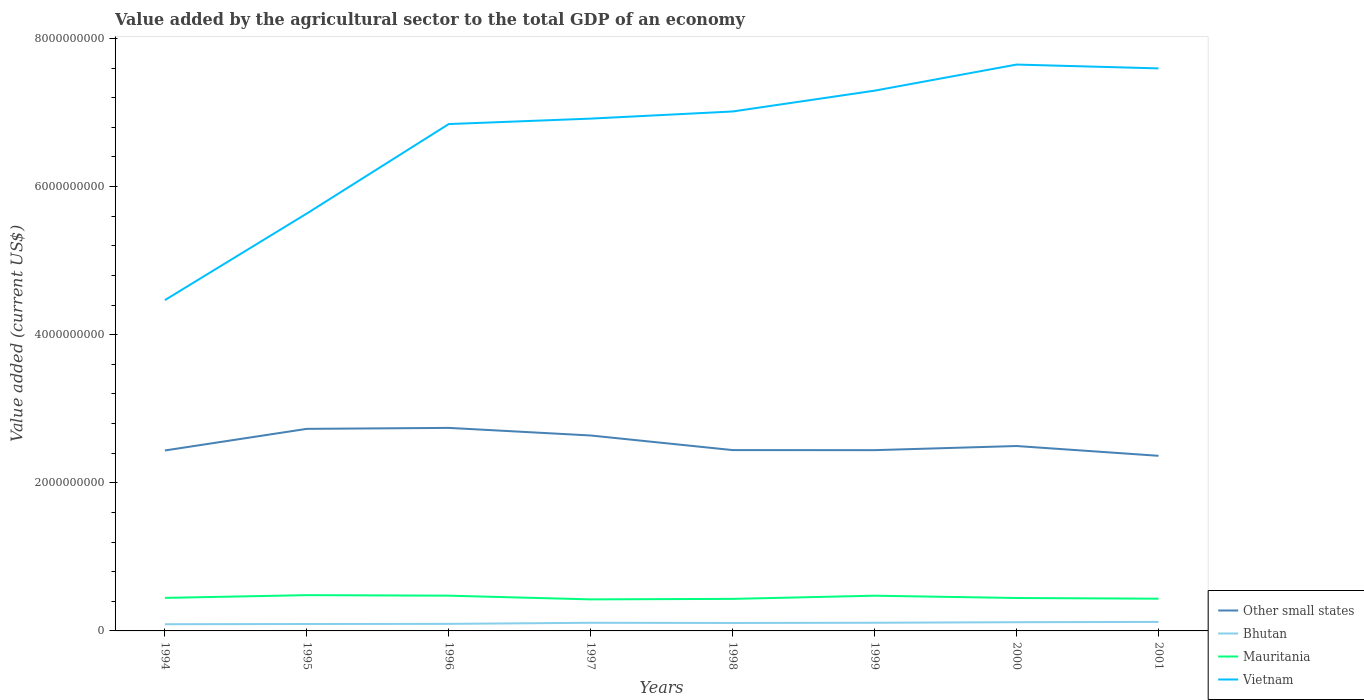How many different coloured lines are there?
Your answer should be very brief. 4. Across all years, what is the maximum value added by the agricultural sector to the total GDP in Mauritania?
Give a very brief answer. 4.26e+08. What is the total value added by the agricultural sector to the total GDP in Bhutan in the graph?
Your answer should be compact. -2.42e+07. What is the difference between the highest and the second highest value added by the agricultural sector to the total GDP in Other small states?
Offer a terse response. 3.77e+08. Are the values on the major ticks of Y-axis written in scientific E-notation?
Offer a terse response. No. What is the title of the graph?
Provide a short and direct response. Value added by the agricultural sector to the total GDP of an economy. Does "Monaco" appear as one of the legend labels in the graph?
Provide a succinct answer. No. What is the label or title of the Y-axis?
Your answer should be very brief. Value added (current US$). What is the Value added (current US$) of Other small states in 1994?
Provide a succinct answer. 2.44e+09. What is the Value added (current US$) in Bhutan in 1994?
Ensure brevity in your answer.  9.05e+07. What is the Value added (current US$) in Mauritania in 1994?
Make the answer very short. 4.46e+08. What is the Value added (current US$) of Vietnam in 1994?
Your answer should be compact. 4.47e+09. What is the Value added (current US$) in Other small states in 1995?
Offer a terse response. 2.73e+09. What is the Value added (current US$) of Bhutan in 1995?
Your answer should be compact. 9.35e+07. What is the Value added (current US$) in Mauritania in 1995?
Your answer should be compact. 4.83e+08. What is the Value added (current US$) of Vietnam in 1995?
Provide a short and direct response. 5.64e+09. What is the Value added (current US$) in Other small states in 1996?
Provide a short and direct response. 2.74e+09. What is the Value added (current US$) in Bhutan in 1996?
Provide a succinct answer. 9.55e+07. What is the Value added (current US$) in Mauritania in 1996?
Your response must be concise. 4.76e+08. What is the Value added (current US$) of Vietnam in 1996?
Your answer should be very brief. 6.84e+09. What is the Value added (current US$) of Other small states in 1997?
Make the answer very short. 2.64e+09. What is the Value added (current US$) in Bhutan in 1997?
Provide a short and direct response. 1.10e+08. What is the Value added (current US$) in Mauritania in 1997?
Your answer should be compact. 4.26e+08. What is the Value added (current US$) in Vietnam in 1997?
Your response must be concise. 6.92e+09. What is the Value added (current US$) of Other small states in 1998?
Keep it short and to the point. 2.44e+09. What is the Value added (current US$) of Bhutan in 1998?
Make the answer very short. 1.07e+08. What is the Value added (current US$) of Mauritania in 1998?
Your response must be concise. 4.33e+08. What is the Value added (current US$) of Vietnam in 1998?
Your answer should be compact. 7.01e+09. What is the Value added (current US$) of Other small states in 1999?
Keep it short and to the point. 2.44e+09. What is the Value added (current US$) of Bhutan in 1999?
Provide a succinct answer. 1.10e+08. What is the Value added (current US$) in Mauritania in 1999?
Make the answer very short. 4.76e+08. What is the Value added (current US$) of Vietnam in 1999?
Your response must be concise. 7.30e+09. What is the Value added (current US$) in Other small states in 2000?
Make the answer very short. 2.50e+09. What is the Value added (current US$) in Bhutan in 2000?
Offer a terse response. 1.18e+08. What is the Value added (current US$) in Mauritania in 2000?
Keep it short and to the point. 4.45e+08. What is the Value added (current US$) of Vietnam in 2000?
Keep it short and to the point. 7.65e+09. What is the Value added (current US$) of Other small states in 2001?
Provide a short and direct response. 2.36e+09. What is the Value added (current US$) of Bhutan in 2001?
Offer a very short reply. 1.22e+08. What is the Value added (current US$) in Mauritania in 2001?
Provide a succinct answer. 4.35e+08. What is the Value added (current US$) in Vietnam in 2001?
Offer a terse response. 7.60e+09. Across all years, what is the maximum Value added (current US$) in Other small states?
Your answer should be compact. 2.74e+09. Across all years, what is the maximum Value added (current US$) in Bhutan?
Offer a terse response. 1.22e+08. Across all years, what is the maximum Value added (current US$) in Mauritania?
Your response must be concise. 4.83e+08. Across all years, what is the maximum Value added (current US$) of Vietnam?
Your answer should be compact. 7.65e+09. Across all years, what is the minimum Value added (current US$) in Other small states?
Make the answer very short. 2.36e+09. Across all years, what is the minimum Value added (current US$) of Bhutan?
Your answer should be compact. 9.05e+07. Across all years, what is the minimum Value added (current US$) of Mauritania?
Provide a succinct answer. 4.26e+08. Across all years, what is the minimum Value added (current US$) of Vietnam?
Offer a very short reply. 4.47e+09. What is the total Value added (current US$) in Other small states in the graph?
Provide a succinct answer. 2.03e+1. What is the total Value added (current US$) in Bhutan in the graph?
Provide a succinct answer. 8.47e+08. What is the total Value added (current US$) in Mauritania in the graph?
Keep it short and to the point. 3.62e+09. What is the total Value added (current US$) of Vietnam in the graph?
Offer a very short reply. 5.34e+1. What is the difference between the Value added (current US$) of Other small states in 1994 and that in 1995?
Offer a very short reply. -2.92e+08. What is the difference between the Value added (current US$) in Bhutan in 1994 and that in 1995?
Your answer should be compact. -2.95e+06. What is the difference between the Value added (current US$) of Mauritania in 1994 and that in 1995?
Ensure brevity in your answer.  -3.70e+07. What is the difference between the Value added (current US$) in Vietnam in 1994 and that in 1995?
Your response must be concise. -1.17e+09. What is the difference between the Value added (current US$) in Other small states in 1994 and that in 1996?
Make the answer very short. -3.05e+08. What is the difference between the Value added (current US$) of Bhutan in 1994 and that in 1996?
Your answer should be very brief. -4.93e+06. What is the difference between the Value added (current US$) in Mauritania in 1994 and that in 1996?
Keep it short and to the point. -3.00e+07. What is the difference between the Value added (current US$) of Vietnam in 1994 and that in 1996?
Make the answer very short. -2.38e+09. What is the difference between the Value added (current US$) in Other small states in 1994 and that in 1997?
Ensure brevity in your answer.  -2.02e+08. What is the difference between the Value added (current US$) of Bhutan in 1994 and that in 1997?
Ensure brevity in your answer.  -1.93e+07. What is the difference between the Value added (current US$) in Mauritania in 1994 and that in 1997?
Give a very brief answer. 2.00e+07. What is the difference between the Value added (current US$) of Vietnam in 1994 and that in 1997?
Make the answer very short. -2.45e+09. What is the difference between the Value added (current US$) of Other small states in 1994 and that in 1998?
Your answer should be compact. -5.21e+06. What is the difference between the Value added (current US$) in Bhutan in 1994 and that in 1998?
Ensure brevity in your answer.  -1.69e+07. What is the difference between the Value added (current US$) of Mauritania in 1994 and that in 1998?
Make the answer very short. 1.33e+07. What is the difference between the Value added (current US$) in Vietnam in 1994 and that in 1998?
Offer a very short reply. -2.55e+09. What is the difference between the Value added (current US$) of Other small states in 1994 and that in 1999?
Your response must be concise. -4.31e+06. What is the difference between the Value added (current US$) in Bhutan in 1994 and that in 1999?
Your answer should be very brief. -1.98e+07. What is the difference between the Value added (current US$) of Mauritania in 1994 and that in 1999?
Ensure brevity in your answer.  -2.94e+07. What is the difference between the Value added (current US$) of Vietnam in 1994 and that in 1999?
Provide a short and direct response. -2.83e+09. What is the difference between the Value added (current US$) of Other small states in 1994 and that in 2000?
Your answer should be compact. -6.03e+07. What is the difference between the Value added (current US$) in Bhutan in 1994 and that in 2000?
Keep it short and to the point. -2.72e+07. What is the difference between the Value added (current US$) in Mauritania in 1994 and that in 2000?
Make the answer very short. 1.50e+06. What is the difference between the Value added (current US$) in Vietnam in 1994 and that in 2000?
Give a very brief answer. -3.18e+09. What is the difference between the Value added (current US$) of Other small states in 1994 and that in 2001?
Your answer should be very brief. 7.18e+07. What is the difference between the Value added (current US$) in Bhutan in 1994 and that in 2001?
Your response must be concise. -3.13e+07. What is the difference between the Value added (current US$) in Mauritania in 1994 and that in 2001?
Keep it short and to the point. 1.09e+07. What is the difference between the Value added (current US$) in Vietnam in 1994 and that in 2001?
Provide a succinct answer. -3.13e+09. What is the difference between the Value added (current US$) of Other small states in 1995 and that in 1996?
Keep it short and to the point. -1.30e+07. What is the difference between the Value added (current US$) of Bhutan in 1995 and that in 1996?
Provide a short and direct response. -1.97e+06. What is the difference between the Value added (current US$) in Mauritania in 1995 and that in 1996?
Your response must be concise. 7.06e+06. What is the difference between the Value added (current US$) in Vietnam in 1995 and that in 1996?
Provide a short and direct response. -1.21e+09. What is the difference between the Value added (current US$) of Other small states in 1995 and that in 1997?
Offer a very short reply. 8.96e+07. What is the difference between the Value added (current US$) in Bhutan in 1995 and that in 1997?
Make the answer very short. -1.64e+07. What is the difference between the Value added (current US$) in Mauritania in 1995 and that in 1997?
Offer a very short reply. 5.71e+07. What is the difference between the Value added (current US$) of Vietnam in 1995 and that in 1997?
Your response must be concise. -1.28e+09. What is the difference between the Value added (current US$) in Other small states in 1995 and that in 1998?
Ensure brevity in your answer.  2.87e+08. What is the difference between the Value added (current US$) in Bhutan in 1995 and that in 1998?
Give a very brief answer. -1.39e+07. What is the difference between the Value added (current US$) in Mauritania in 1995 and that in 1998?
Provide a succinct answer. 5.03e+07. What is the difference between the Value added (current US$) of Vietnam in 1995 and that in 1998?
Provide a succinct answer. -1.38e+09. What is the difference between the Value added (current US$) in Other small states in 1995 and that in 1999?
Offer a very short reply. 2.88e+08. What is the difference between the Value added (current US$) of Bhutan in 1995 and that in 1999?
Provide a succinct answer. -1.69e+07. What is the difference between the Value added (current US$) in Mauritania in 1995 and that in 1999?
Your answer should be very brief. 7.61e+06. What is the difference between the Value added (current US$) of Vietnam in 1995 and that in 1999?
Give a very brief answer. -1.66e+09. What is the difference between the Value added (current US$) in Other small states in 1995 and that in 2000?
Your answer should be very brief. 2.32e+08. What is the difference between the Value added (current US$) of Bhutan in 1995 and that in 2000?
Your answer should be very brief. -2.42e+07. What is the difference between the Value added (current US$) in Mauritania in 1995 and that in 2000?
Offer a very short reply. 3.85e+07. What is the difference between the Value added (current US$) in Vietnam in 1995 and that in 2000?
Provide a short and direct response. -2.01e+09. What is the difference between the Value added (current US$) of Other small states in 1995 and that in 2001?
Your response must be concise. 3.64e+08. What is the difference between the Value added (current US$) of Bhutan in 1995 and that in 2001?
Offer a very short reply. -2.83e+07. What is the difference between the Value added (current US$) of Mauritania in 1995 and that in 2001?
Give a very brief answer. 4.79e+07. What is the difference between the Value added (current US$) of Vietnam in 1995 and that in 2001?
Make the answer very short. -1.96e+09. What is the difference between the Value added (current US$) in Other small states in 1996 and that in 1997?
Offer a very short reply. 1.03e+08. What is the difference between the Value added (current US$) in Bhutan in 1996 and that in 1997?
Your response must be concise. -1.44e+07. What is the difference between the Value added (current US$) of Mauritania in 1996 and that in 1997?
Offer a terse response. 5.00e+07. What is the difference between the Value added (current US$) of Vietnam in 1996 and that in 1997?
Offer a terse response. -7.35e+07. What is the difference between the Value added (current US$) of Other small states in 1996 and that in 1998?
Provide a succinct answer. 3.00e+08. What is the difference between the Value added (current US$) in Bhutan in 1996 and that in 1998?
Give a very brief answer. -1.20e+07. What is the difference between the Value added (current US$) in Mauritania in 1996 and that in 1998?
Your response must be concise. 4.32e+07. What is the difference between the Value added (current US$) in Vietnam in 1996 and that in 1998?
Your response must be concise. -1.70e+08. What is the difference between the Value added (current US$) of Other small states in 1996 and that in 1999?
Your answer should be compact. 3.01e+08. What is the difference between the Value added (current US$) in Bhutan in 1996 and that in 1999?
Give a very brief answer. -1.49e+07. What is the difference between the Value added (current US$) of Mauritania in 1996 and that in 1999?
Provide a succinct answer. 5.43e+05. What is the difference between the Value added (current US$) of Vietnam in 1996 and that in 1999?
Offer a very short reply. -4.51e+08. What is the difference between the Value added (current US$) of Other small states in 1996 and that in 2000?
Offer a terse response. 2.45e+08. What is the difference between the Value added (current US$) in Bhutan in 1996 and that in 2000?
Offer a terse response. -2.22e+07. What is the difference between the Value added (current US$) of Mauritania in 1996 and that in 2000?
Your answer should be compact. 3.15e+07. What is the difference between the Value added (current US$) in Vietnam in 1996 and that in 2000?
Your answer should be compact. -8.03e+08. What is the difference between the Value added (current US$) in Other small states in 1996 and that in 2001?
Give a very brief answer. 3.77e+08. What is the difference between the Value added (current US$) of Bhutan in 1996 and that in 2001?
Provide a succinct answer. -2.64e+07. What is the difference between the Value added (current US$) of Mauritania in 1996 and that in 2001?
Your answer should be compact. 4.09e+07. What is the difference between the Value added (current US$) in Vietnam in 1996 and that in 2001?
Provide a short and direct response. -7.52e+08. What is the difference between the Value added (current US$) in Other small states in 1997 and that in 1998?
Your answer should be very brief. 1.97e+08. What is the difference between the Value added (current US$) of Bhutan in 1997 and that in 1998?
Provide a short and direct response. 2.43e+06. What is the difference between the Value added (current US$) of Mauritania in 1997 and that in 1998?
Offer a very short reply. -6.77e+06. What is the difference between the Value added (current US$) of Vietnam in 1997 and that in 1998?
Provide a short and direct response. -9.64e+07. What is the difference between the Value added (current US$) in Other small states in 1997 and that in 1999?
Keep it short and to the point. 1.98e+08. What is the difference between the Value added (current US$) of Bhutan in 1997 and that in 1999?
Provide a succinct answer. -5.05e+05. What is the difference between the Value added (current US$) of Mauritania in 1997 and that in 1999?
Your answer should be compact. -4.95e+07. What is the difference between the Value added (current US$) in Vietnam in 1997 and that in 1999?
Provide a short and direct response. -3.77e+08. What is the difference between the Value added (current US$) of Other small states in 1997 and that in 2000?
Give a very brief answer. 1.42e+08. What is the difference between the Value added (current US$) of Bhutan in 1997 and that in 2000?
Your answer should be very brief. -7.86e+06. What is the difference between the Value added (current US$) in Mauritania in 1997 and that in 2000?
Your response must be concise. -1.85e+07. What is the difference between the Value added (current US$) of Vietnam in 1997 and that in 2000?
Ensure brevity in your answer.  -7.30e+08. What is the difference between the Value added (current US$) in Other small states in 1997 and that in 2001?
Ensure brevity in your answer.  2.74e+08. What is the difference between the Value added (current US$) of Bhutan in 1997 and that in 2001?
Your response must be concise. -1.20e+07. What is the difference between the Value added (current US$) of Mauritania in 1997 and that in 2001?
Give a very brief answer. -9.14e+06. What is the difference between the Value added (current US$) of Vietnam in 1997 and that in 2001?
Ensure brevity in your answer.  -6.78e+08. What is the difference between the Value added (current US$) of Other small states in 1998 and that in 1999?
Provide a succinct answer. 9.06e+05. What is the difference between the Value added (current US$) in Bhutan in 1998 and that in 1999?
Provide a succinct answer. -2.93e+06. What is the difference between the Value added (current US$) of Mauritania in 1998 and that in 1999?
Keep it short and to the point. -4.27e+07. What is the difference between the Value added (current US$) in Vietnam in 1998 and that in 1999?
Your response must be concise. -2.81e+08. What is the difference between the Value added (current US$) in Other small states in 1998 and that in 2000?
Make the answer very short. -5.51e+07. What is the difference between the Value added (current US$) in Bhutan in 1998 and that in 2000?
Ensure brevity in your answer.  -1.03e+07. What is the difference between the Value added (current US$) of Mauritania in 1998 and that in 2000?
Keep it short and to the point. -1.18e+07. What is the difference between the Value added (current US$) in Vietnam in 1998 and that in 2000?
Your answer should be compact. -6.34e+08. What is the difference between the Value added (current US$) of Other small states in 1998 and that in 2001?
Provide a short and direct response. 7.70e+07. What is the difference between the Value added (current US$) in Bhutan in 1998 and that in 2001?
Your response must be concise. -1.44e+07. What is the difference between the Value added (current US$) of Mauritania in 1998 and that in 2001?
Offer a terse response. -2.37e+06. What is the difference between the Value added (current US$) in Vietnam in 1998 and that in 2001?
Provide a short and direct response. -5.82e+08. What is the difference between the Value added (current US$) in Other small states in 1999 and that in 2000?
Provide a succinct answer. -5.60e+07. What is the difference between the Value added (current US$) of Bhutan in 1999 and that in 2000?
Make the answer very short. -7.35e+06. What is the difference between the Value added (current US$) in Mauritania in 1999 and that in 2000?
Provide a short and direct response. 3.09e+07. What is the difference between the Value added (current US$) of Vietnam in 1999 and that in 2000?
Provide a succinct answer. -3.53e+08. What is the difference between the Value added (current US$) of Other small states in 1999 and that in 2001?
Make the answer very short. 7.61e+07. What is the difference between the Value added (current US$) in Bhutan in 1999 and that in 2001?
Your response must be concise. -1.15e+07. What is the difference between the Value added (current US$) of Mauritania in 1999 and that in 2001?
Keep it short and to the point. 4.03e+07. What is the difference between the Value added (current US$) of Vietnam in 1999 and that in 2001?
Offer a very short reply. -3.01e+08. What is the difference between the Value added (current US$) in Other small states in 2000 and that in 2001?
Offer a very short reply. 1.32e+08. What is the difference between the Value added (current US$) of Bhutan in 2000 and that in 2001?
Keep it short and to the point. -4.12e+06. What is the difference between the Value added (current US$) of Mauritania in 2000 and that in 2001?
Make the answer very short. 9.40e+06. What is the difference between the Value added (current US$) of Vietnam in 2000 and that in 2001?
Your answer should be compact. 5.17e+07. What is the difference between the Value added (current US$) in Other small states in 1994 and the Value added (current US$) in Bhutan in 1995?
Offer a very short reply. 2.34e+09. What is the difference between the Value added (current US$) of Other small states in 1994 and the Value added (current US$) of Mauritania in 1995?
Your answer should be very brief. 1.95e+09. What is the difference between the Value added (current US$) of Other small states in 1994 and the Value added (current US$) of Vietnam in 1995?
Provide a succinct answer. -3.20e+09. What is the difference between the Value added (current US$) of Bhutan in 1994 and the Value added (current US$) of Mauritania in 1995?
Give a very brief answer. -3.93e+08. What is the difference between the Value added (current US$) in Bhutan in 1994 and the Value added (current US$) in Vietnam in 1995?
Provide a short and direct response. -5.55e+09. What is the difference between the Value added (current US$) of Mauritania in 1994 and the Value added (current US$) of Vietnam in 1995?
Ensure brevity in your answer.  -5.19e+09. What is the difference between the Value added (current US$) of Other small states in 1994 and the Value added (current US$) of Bhutan in 1996?
Your answer should be compact. 2.34e+09. What is the difference between the Value added (current US$) of Other small states in 1994 and the Value added (current US$) of Mauritania in 1996?
Keep it short and to the point. 1.96e+09. What is the difference between the Value added (current US$) of Other small states in 1994 and the Value added (current US$) of Vietnam in 1996?
Keep it short and to the point. -4.41e+09. What is the difference between the Value added (current US$) in Bhutan in 1994 and the Value added (current US$) in Mauritania in 1996?
Offer a very short reply. -3.86e+08. What is the difference between the Value added (current US$) of Bhutan in 1994 and the Value added (current US$) of Vietnam in 1996?
Your response must be concise. -6.75e+09. What is the difference between the Value added (current US$) of Mauritania in 1994 and the Value added (current US$) of Vietnam in 1996?
Make the answer very short. -6.40e+09. What is the difference between the Value added (current US$) of Other small states in 1994 and the Value added (current US$) of Bhutan in 1997?
Your answer should be compact. 2.33e+09. What is the difference between the Value added (current US$) in Other small states in 1994 and the Value added (current US$) in Mauritania in 1997?
Offer a terse response. 2.01e+09. What is the difference between the Value added (current US$) of Other small states in 1994 and the Value added (current US$) of Vietnam in 1997?
Offer a terse response. -4.48e+09. What is the difference between the Value added (current US$) in Bhutan in 1994 and the Value added (current US$) in Mauritania in 1997?
Provide a short and direct response. -3.36e+08. What is the difference between the Value added (current US$) in Bhutan in 1994 and the Value added (current US$) in Vietnam in 1997?
Make the answer very short. -6.83e+09. What is the difference between the Value added (current US$) of Mauritania in 1994 and the Value added (current US$) of Vietnam in 1997?
Provide a succinct answer. -6.47e+09. What is the difference between the Value added (current US$) in Other small states in 1994 and the Value added (current US$) in Bhutan in 1998?
Ensure brevity in your answer.  2.33e+09. What is the difference between the Value added (current US$) in Other small states in 1994 and the Value added (current US$) in Mauritania in 1998?
Give a very brief answer. 2.00e+09. What is the difference between the Value added (current US$) in Other small states in 1994 and the Value added (current US$) in Vietnam in 1998?
Offer a terse response. -4.58e+09. What is the difference between the Value added (current US$) in Bhutan in 1994 and the Value added (current US$) in Mauritania in 1998?
Ensure brevity in your answer.  -3.42e+08. What is the difference between the Value added (current US$) in Bhutan in 1994 and the Value added (current US$) in Vietnam in 1998?
Provide a short and direct response. -6.92e+09. What is the difference between the Value added (current US$) of Mauritania in 1994 and the Value added (current US$) of Vietnam in 1998?
Provide a short and direct response. -6.57e+09. What is the difference between the Value added (current US$) in Other small states in 1994 and the Value added (current US$) in Bhutan in 1999?
Offer a terse response. 2.33e+09. What is the difference between the Value added (current US$) of Other small states in 1994 and the Value added (current US$) of Mauritania in 1999?
Provide a succinct answer. 1.96e+09. What is the difference between the Value added (current US$) of Other small states in 1994 and the Value added (current US$) of Vietnam in 1999?
Your answer should be very brief. -4.86e+09. What is the difference between the Value added (current US$) in Bhutan in 1994 and the Value added (current US$) in Mauritania in 1999?
Your answer should be compact. -3.85e+08. What is the difference between the Value added (current US$) of Bhutan in 1994 and the Value added (current US$) of Vietnam in 1999?
Provide a succinct answer. -7.21e+09. What is the difference between the Value added (current US$) in Mauritania in 1994 and the Value added (current US$) in Vietnam in 1999?
Offer a terse response. -6.85e+09. What is the difference between the Value added (current US$) in Other small states in 1994 and the Value added (current US$) in Bhutan in 2000?
Make the answer very short. 2.32e+09. What is the difference between the Value added (current US$) of Other small states in 1994 and the Value added (current US$) of Mauritania in 2000?
Provide a short and direct response. 1.99e+09. What is the difference between the Value added (current US$) of Other small states in 1994 and the Value added (current US$) of Vietnam in 2000?
Make the answer very short. -5.21e+09. What is the difference between the Value added (current US$) of Bhutan in 1994 and the Value added (current US$) of Mauritania in 2000?
Provide a succinct answer. -3.54e+08. What is the difference between the Value added (current US$) of Bhutan in 1994 and the Value added (current US$) of Vietnam in 2000?
Provide a succinct answer. -7.56e+09. What is the difference between the Value added (current US$) in Mauritania in 1994 and the Value added (current US$) in Vietnam in 2000?
Provide a short and direct response. -7.20e+09. What is the difference between the Value added (current US$) of Other small states in 1994 and the Value added (current US$) of Bhutan in 2001?
Provide a short and direct response. 2.31e+09. What is the difference between the Value added (current US$) in Other small states in 1994 and the Value added (current US$) in Mauritania in 2001?
Provide a succinct answer. 2.00e+09. What is the difference between the Value added (current US$) of Other small states in 1994 and the Value added (current US$) of Vietnam in 2001?
Ensure brevity in your answer.  -5.16e+09. What is the difference between the Value added (current US$) in Bhutan in 1994 and the Value added (current US$) in Mauritania in 2001?
Make the answer very short. -3.45e+08. What is the difference between the Value added (current US$) of Bhutan in 1994 and the Value added (current US$) of Vietnam in 2001?
Offer a very short reply. -7.51e+09. What is the difference between the Value added (current US$) of Mauritania in 1994 and the Value added (current US$) of Vietnam in 2001?
Give a very brief answer. -7.15e+09. What is the difference between the Value added (current US$) in Other small states in 1995 and the Value added (current US$) in Bhutan in 1996?
Your answer should be very brief. 2.63e+09. What is the difference between the Value added (current US$) in Other small states in 1995 and the Value added (current US$) in Mauritania in 1996?
Offer a very short reply. 2.25e+09. What is the difference between the Value added (current US$) of Other small states in 1995 and the Value added (current US$) of Vietnam in 1996?
Your answer should be compact. -4.12e+09. What is the difference between the Value added (current US$) of Bhutan in 1995 and the Value added (current US$) of Mauritania in 1996?
Provide a succinct answer. -3.83e+08. What is the difference between the Value added (current US$) of Bhutan in 1995 and the Value added (current US$) of Vietnam in 1996?
Make the answer very short. -6.75e+09. What is the difference between the Value added (current US$) in Mauritania in 1995 and the Value added (current US$) in Vietnam in 1996?
Offer a very short reply. -6.36e+09. What is the difference between the Value added (current US$) of Other small states in 1995 and the Value added (current US$) of Bhutan in 1997?
Provide a short and direct response. 2.62e+09. What is the difference between the Value added (current US$) of Other small states in 1995 and the Value added (current US$) of Mauritania in 1997?
Offer a terse response. 2.30e+09. What is the difference between the Value added (current US$) in Other small states in 1995 and the Value added (current US$) in Vietnam in 1997?
Ensure brevity in your answer.  -4.19e+09. What is the difference between the Value added (current US$) in Bhutan in 1995 and the Value added (current US$) in Mauritania in 1997?
Offer a very short reply. -3.33e+08. What is the difference between the Value added (current US$) of Bhutan in 1995 and the Value added (current US$) of Vietnam in 1997?
Provide a succinct answer. -6.82e+09. What is the difference between the Value added (current US$) in Mauritania in 1995 and the Value added (current US$) in Vietnam in 1997?
Ensure brevity in your answer.  -6.43e+09. What is the difference between the Value added (current US$) of Other small states in 1995 and the Value added (current US$) of Bhutan in 1998?
Your response must be concise. 2.62e+09. What is the difference between the Value added (current US$) in Other small states in 1995 and the Value added (current US$) in Mauritania in 1998?
Give a very brief answer. 2.30e+09. What is the difference between the Value added (current US$) in Other small states in 1995 and the Value added (current US$) in Vietnam in 1998?
Offer a terse response. -4.29e+09. What is the difference between the Value added (current US$) in Bhutan in 1995 and the Value added (current US$) in Mauritania in 1998?
Your answer should be very brief. -3.39e+08. What is the difference between the Value added (current US$) in Bhutan in 1995 and the Value added (current US$) in Vietnam in 1998?
Keep it short and to the point. -6.92e+09. What is the difference between the Value added (current US$) in Mauritania in 1995 and the Value added (current US$) in Vietnam in 1998?
Make the answer very short. -6.53e+09. What is the difference between the Value added (current US$) of Other small states in 1995 and the Value added (current US$) of Bhutan in 1999?
Make the answer very short. 2.62e+09. What is the difference between the Value added (current US$) of Other small states in 1995 and the Value added (current US$) of Mauritania in 1999?
Keep it short and to the point. 2.25e+09. What is the difference between the Value added (current US$) of Other small states in 1995 and the Value added (current US$) of Vietnam in 1999?
Your response must be concise. -4.57e+09. What is the difference between the Value added (current US$) in Bhutan in 1995 and the Value added (current US$) in Mauritania in 1999?
Your answer should be compact. -3.82e+08. What is the difference between the Value added (current US$) in Bhutan in 1995 and the Value added (current US$) in Vietnam in 1999?
Make the answer very short. -7.20e+09. What is the difference between the Value added (current US$) in Mauritania in 1995 and the Value added (current US$) in Vietnam in 1999?
Offer a terse response. -6.81e+09. What is the difference between the Value added (current US$) of Other small states in 1995 and the Value added (current US$) of Bhutan in 2000?
Make the answer very short. 2.61e+09. What is the difference between the Value added (current US$) of Other small states in 1995 and the Value added (current US$) of Mauritania in 2000?
Keep it short and to the point. 2.28e+09. What is the difference between the Value added (current US$) of Other small states in 1995 and the Value added (current US$) of Vietnam in 2000?
Offer a terse response. -4.92e+09. What is the difference between the Value added (current US$) of Bhutan in 1995 and the Value added (current US$) of Mauritania in 2000?
Your response must be concise. -3.51e+08. What is the difference between the Value added (current US$) in Bhutan in 1995 and the Value added (current US$) in Vietnam in 2000?
Provide a succinct answer. -7.55e+09. What is the difference between the Value added (current US$) in Mauritania in 1995 and the Value added (current US$) in Vietnam in 2000?
Keep it short and to the point. -7.16e+09. What is the difference between the Value added (current US$) in Other small states in 1995 and the Value added (current US$) in Bhutan in 2001?
Give a very brief answer. 2.61e+09. What is the difference between the Value added (current US$) of Other small states in 1995 and the Value added (current US$) of Mauritania in 2001?
Give a very brief answer. 2.29e+09. What is the difference between the Value added (current US$) of Other small states in 1995 and the Value added (current US$) of Vietnam in 2001?
Keep it short and to the point. -4.87e+09. What is the difference between the Value added (current US$) in Bhutan in 1995 and the Value added (current US$) in Mauritania in 2001?
Ensure brevity in your answer.  -3.42e+08. What is the difference between the Value added (current US$) in Bhutan in 1995 and the Value added (current US$) in Vietnam in 2001?
Offer a terse response. -7.50e+09. What is the difference between the Value added (current US$) of Mauritania in 1995 and the Value added (current US$) of Vietnam in 2001?
Provide a short and direct response. -7.11e+09. What is the difference between the Value added (current US$) in Other small states in 1996 and the Value added (current US$) in Bhutan in 1997?
Give a very brief answer. 2.63e+09. What is the difference between the Value added (current US$) in Other small states in 1996 and the Value added (current US$) in Mauritania in 1997?
Keep it short and to the point. 2.32e+09. What is the difference between the Value added (current US$) in Other small states in 1996 and the Value added (current US$) in Vietnam in 1997?
Ensure brevity in your answer.  -4.18e+09. What is the difference between the Value added (current US$) in Bhutan in 1996 and the Value added (current US$) in Mauritania in 1997?
Provide a short and direct response. -3.31e+08. What is the difference between the Value added (current US$) of Bhutan in 1996 and the Value added (current US$) of Vietnam in 1997?
Make the answer very short. -6.82e+09. What is the difference between the Value added (current US$) in Mauritania in 1996 and the Value added (current US$) in Vietnam in 1997?
Offer a terse response. -6.44e+09. What is the difference between the Value added (current US$) in Other small states in 1996 and the Value added (current US$) in Bhutan in 1998?
Ensure brevity in your answer.  2.63e+09. What is the difference between the Value added (current US$) of Other small states in 1996 and the Value added (current US$) of Mauritania in 1998?
Your answer should be very brief. 2.31e+09. What is the difference between the Value added (current US$) of Other small states in 1996 and the Value added (current US$) of Vietnam in 1998?
Offer a very short reply. -4.27e+09. What is the difference between the Value added (current US$) of Bhutan in 1996 and the Value added (current US$) of Mauritania in 1998?
Make the answer very short. -3.37e+08. What is the difference between the Value added (current US$) in Bhutan in 1996 and the Value added (current US$) in Vietnam in 1998?
Keep it short and to the point. -6.92e+09. What is the difference between the Value added (current US$) of Mauritania in 1996 and the Value added (current US$) of Vietnam in 1998?
Your answer should be very brief. -6.54e+09. What is the difference between the Value added (current US$) of Other small states in 1996 and the Value added (current US$) of Bhutan in 1999?
Make the answer very short. 2.63e+09. What is the difference between the Value added (current US$) in Other small states in 1996 and the Value added (current US$) in Mauritania in 1999?
Your response must be concise. 2.27e+09. What is the difference between the Value added (current US$) in Other small states in 1996 and the Value added (current US$) in Vietnam in 1999?
Offer a terse response. -4.55e+09. What is the difference between the Value added (current US$) in Bhutan in 1996 and the Value added (current US$) in Mauritania in 1999?
Offer a terse response. -3.80e+08. What is the difference between the Value added (current US$) in Bhutan in 1996 and the Value added (current US$) in Vietnam in 1999?
Your answer should be compact. -7.20e+09. What is the difference between the Value added (current US$) in Mauritania in 1996 and the Value added (current US$) in Vietnam in 1999?
Provide a short and direct response. -6.82e+09. What is the difference between the Value added (current US$) of Other small states in 1996 and the Value added (current US$) of Bhutan in 2000?
Keep it short and to the point. 2.62e+09. What is the difference between the Value added (current US$) of Other small states in 1996 and the Value added (current US$) of Mauritania in 2000?
Provide a succinct answer. 2.30e+09. What is the difference between the Value added (current US$) of Other small states in 1996 and the Value added (current US$) of Vietnam in 2000?
Your answer should be very brief. -4.91e+09. What is the difference between the Value added (current US$) of Bhutan in 1996 and the Value added (current US$) of Mauritania in 2000?
Your answer should be very brief. -3.49e+08. What is the difference between the Value added (current US$) in Bhutan in 1996 and the Value added (current US$) in Vietnam in 2000?
Provide a succinct answer. -7.55e+09. What is the difference between the Value added (current US$) in Mauritania in 1996 and the Value added (current US$) in Vietnam in 2000?
Keep it short and to the point. -7.17e+09. What is the difference between the Value added (current US$) of Other small states in 1996 and the Value added (current US$) of Bhutan in 2001?
Give a very brief answer. 2.62e+09. What is the difference between the Value added (current US$) of Other small states in 1996 and the Value added (current US$) of Mauritania in 2001?
Offer a very short reply. 2.31e+09. What is the difference between the Value added (current US$) of Other small states in 1996 and the Value added (current US$) of Vietnam in 2001?
Your answer should be compact. -4.85e+09. What is the difference between the Value added (current US$) of Bhutan in 1996 and the Value added (current US$) of Mauritania in 2001?
Offer a very short reply. -3.40e+08. What is the difference between the Value added (current US$) of Bhutan in 1996 and the Value added (current US$) of Vietnam in 2001?
Keep it short and to the point. -7.50e+09. What is the difference between the Value added (current US$) of Mauritania in 1996 and the Value added (current US$) of Vietnam in 2001?
Your response must be concise. -7.12e+09. What is the difference between the Value added (current US$) of Other small states in 1997 and the Value added (current US$) of Bhutan in 1998?
Make the answer very short. 2.53e+09. What is the difference between the Value added (current US$) of Other small states in 1997 and the Value added (current US$) of Mauritania in 1998?
Your answer should be very brief. 2.21e+09. What is the difference between the Value added (current US$) in Other small states in 1997 and the Value added (current US$) in Vietnam in 1998?
Provide a short and direct response. -4.38e+09. What is the difference between the Value added (current US$) in Bhutan in 1997 and the Value added (current US$) in Mauritania in 1998?
Your response must be concise. -3.23e+08. What is the difference between the Value added (current US$) in Bhutan in 1997 and the Value added (current US$) in Vietnam in 1998?
Your response must be concise. -6.90e+09. What is the difference between the Value added (current US$) in Mauritania in 1997 and the Value added (current US$) in Vietnam in 1998?
Give a very brief answer. -6.59e+09. What is the difference between the Value added (current US$) of Other small states in 1997 and the Value added (current US$) of Bhutan in 1999?
Keep it short and to the point. 2.53e+09. What is the difference between the Value added (current US$) of Other small states in 1997 and the Value added (current US$) of Mauritania in 1999?
Ensure brevity in your answer.  2.16e+09. What is the difference between the Value added (current US$) in Other small states in 1997 and the Value added (current US$) in Vietnam in 1999?
Your response must be concise. -4.66e+09. What is the difference between the Value added (current US$) in Bhutan in 1997 and the Value added (current US$) in Mauritania in 1999?
Make the answer very short. -3.66e+08. What is the difference between the Value added (current US$) in Bhutan in 1997 and the Value added (current US$) in Vietnam in 1999?
Ensure brevity in your answer.  -7.19e+09. What is the difference between the Value added (current US$) of Mauritania in 1997 and the Value added (current US$) of Vietnam in 1999?
Keep it short and to the point. -6.87e+09. What is the difference between the Value added (current US$) in Other small states in 1997 and the Value added (current US$) in Bhutan in 2000?
Your answer should be very brief. 2.52e+09. What is the difference between the Value added (current US$) in Other small states in 1997 and the Value added (current US$) in Mauritania in 2000?
Your response must be concise. 2.19e+09. What is the difference between the Value added (current US$) in Other small states in 1997 and the Value added (current US$) in Vietnam in 2000?
Keep it short and to the point. -5.01e+09. What is the difference between the Value added (current US$) of Bhutan in 1997 and the Value added (current US$) of Mauritania in 2000?
Give a very brief answer. -3.35e+08. What is the difference between the Value added (current US$) in Bhutan in 1997 and the Value added (current US$) in Vietnam in 2000?
Ensure brevity in your answer.  -7.54e+09. What is the difference between the Value added (current US$) in Mauritania in 1997 and the Value added (current US$) in Vietnam in 2000?
Your response must be concise. -7.22e+09. What is the difference between the Value added (current US$) of Other small states in 1997 and the Value added (current US$) of Bhutan in 2001?
Your response must be concise. 2.52e+09. What is the difference between the Value added (current US$) of Other small states in 1997 and the Value added (current US$) of Mauritania in 2001?
Provide a succinct answer. 2.20e+09. What is the difference between the Value added (current US$) of Other small states in 1997 and the Value added (current US$) of Vietnam in 2001?
Make the answer very short. -4.96e+09. What is the difference between the Value added (current US$) of Bhutan in 1997 and the Value added (current US$) of Mauritania in 2001?
Your response must be concise. -3.25e+08. What is the difference between the Value added (current US$) of Bhutan in 1997 and the Value added (current US$) of Vietnam in 2001?
Provide a short and direct response. -7.49e+09. What is the difference between the Value added (current US$) in Mauritania in 1997 and the Value added (current US$) in Vietnam in 2001?
Offer a terse response. -7.17e+09. What is the difference between the Value added (current US$) of Other small states in 1998 and the Value added (current US$) of Bhutan in 1999?
Offer a very short reply. 2.33e+09. What is the difference between the Value added (current US$) in Other small states in 1998 and the Value added (current US$) in Mauritania in 1999?
Your answer should be compact. 1.97e+09. What is the difference between the Value added (current US$) in Other small states in 1998 and the Value added (current US$) in Vietnam in 1999?
Give a very brief answer. -4.85e+09. What is the difference between the Value added (current US$) of Bhutan in 1998 and the Value added (current US$) of Mauritania in 1999?
Provide a succinct answer. -3.68e+08. What is the difference between the Value added (current US$) in Bhutan in 1998 and the Value added (current US$) in Vietnam in 1999?
Ensure brevity in your answer.  -7.19e+09. What is the difference between the Value added (current US$) in Mauritania in 1998 and the Value added (current US$) in Vietnam in 1999?
Provide a short and direct response. -6.86e+09. What is the difference between the Value added (current US$) in Other small states in 1998 and the Value added (current US$) in Bhutan in 2000?
Offer a terse response. 2.32e+09. What is the difference between the Value added (current US$) of Other small states in 1998 and the Value added (current US$) of Mauritania in 2000?
Keep it short and to the point. 2.00e+09. What is the difference between the Value added (current US$) of Other small states in 1998 and the Value added (current US$) of Vietnam in 2000?
Provide a short and direct response. -5.21e+09. What is the difference between the Value added (current US$) in Bhutan in 1998 and the Value added (current US$) in Mauritania in 2000?
Offer a terse response. -3.37e+08. What is the difference between the Value added (current US$) in Bhutan in 1998 and the Value added (current US$) in Vietnam in 2000?
Your answer should be very brief. -7.54e+09. What is the difference between the Value added (current US$) in Mauritania in 1998 and the Value added (current US$) in Vietnam in 2000?
Provide a succinct answer. -7.22e+09. What is the difference between the Value added (current US$) of Other small states in 1998 and the Value added (current US$) of Bhutan in 2001?
Ensure brevity in your answer.  2.32e+09. What is the difference between the Value added (current US$) of Other small states in 1998 and the Value added (current US$) of Mauritania in 2001?
Keep it short and to the point. 2.01e+09. What is the difference between the Value added (current US$) in Other small states in 1998 and the Value added (current US$) in Vietnam in 2001?
Your answer should be compact. -5.15e+09. What is the difference between the Value added (current US$) in Bhutan in 1998 and the Value added (current US$) in Mauritania in 2001?
Ensure brevity in your answer.  -3.28e+08. What is the difference between the Value added (current US$) in Bhutan in 1998 and the Value added (current US$) in Vietnam in 2001?
Your answer should be compact. -7.49e+09. What is the difference between the Value added (current US$) of Mauritania in 1998 and the Value added (current US$) of Vietnam in 2001?
Provide a succinct answer. -7.16e+09. What is the difference between the Value added (current US$) in Other small states in 1999 and the Value added (current US$) in Bhutan in 2000?
Keep it short and to the point. 2.32e+09. What is the difference between the Value added (current US$) of Other small states in 1999 and the Value added (current US$) of Mauritania in 2000?
Give a very brief answer. 2.00e+09. What is the difference between the Value added (current US$) of Other small states in 1999 and the Value added (current US$) of Vietnam in 2000?
Offer a very short reply. -5.21e+09. What is the difference between the Value added (current US$) of Bhutan in 1999 and the Value added (current US$) of Mauritania in 2000?
Offer a very short reply. -3.34e+08. What is the difference between the Value added (current US$) in Bhutan in 1999 and the Value added (current US$) in Vietnam in 2000?
Make the answer very short. -7.54e+09. What is the difference between the Value added (current US$) of Mauritania in 1999 and the Value added (current US$) of Vietnam in 2000?
Make the answer very short. -7.17e+09. What is the difference between the Value added (current US$) of Other small states in 1999 and the Value added (current US$) of Bhutan in 2001?
Your response must be concise. 2.32e+09. What is the difference between the Value added (current US$) in Other small states in 1999 and the Value added (current US$) in Mauritania in 2001?
Provide a succinct answer. 2.01e+09. What is the difference between the Value added (current US$) of Other small states in 1999 and the Value added (current US$) of Vietnam in 2001?
Give a very brief answer. -5.16e+09. What is the difference between the Value added (current US$) in Bhutan in 1999 and the Value added (current US$) in Mauritania in 2001?
Your answer should be very brief. -3.25e+08. What is the difference between the Value added (current US$) of Bhutan in 1999 and the Value added (current US$) of Vietnam in 2001?
Keep it short and to the point. -7.49e+09. What is the difference between the Value added (current US$) in Mauritania in 1999 and the Value added (current US$) in Vietnam in 2001?
Your answer should be very brief. -7.12e+09. What is the difference between the Value added (current US$) of Other small states in 2000 and the Value added (current US$) of Bhutan in 2001?
Provide a short and direct response. 2.38e+09. What is the difference between the Value added (current US$) of Other small states in 2000 and the Value added (current US$) of Mauritania in 2001?
Offer a terse response. 2.06e+09. What is the difference between the Value added (current US$) in Other small states in 2000 and the Value added (current US$) in Vietnam in 2001?
Your response must be concise. -5.10e+09. What is the difference between the Value added (current US$) in Bhutan in 2000 and the Value added (current US$) in Mauritania in 2001?
Ensure brevity in your answer.  -3.17e+08. What is the difference between the Value added (current US$) in Bhutan in 2000 and the Value added (current US$) in Vietnam in 2001?
Offer a terse response. -7.48e+09. What is the difference between the Value added (current US$) in Mauritania in 2000 and the Value added (current US$) in Vietnam in 2001?
Provide a short and direct response. -7.15e+09. What is the average Value added (current US$) in Other small states per year?
Make the answer very short. 2.54e+09. What is the average Value added (current US$) in Bhutan per year?
Your response must be concise. 1.06e+08. What is the average Value added (current US$) in Mauritania per year?
Ensure brevity in your answer.  4.52e+08. What is the average Value added (current US$) in Vietnam per year?
Offer a very short reply. 6.68e+09. In the year 1994, what is the difference between the Value added (current US$) of Other small states and Value added (current US$) of Bhutan?
Your answer should be compact. 2.35e+09. In the year 1994, what is the difference between the Value added (current US$) in Other small states and Value added (current US$) in Mauritania?
Offer a very short reply. 1.99e+09. In the year 1994, what is the difference between the Value added (current US$) in Other small states and Value added (current US$) in Vietnam?
Provide a short and direct response. -2.03e+09. In the year 1994, what is the difference between the Value added (current US$) of Bhutan and Value added (current US$) of Mauritania?
Your response must be concise. -3.56e+08. In the year 1994, what is the difference between the Value added (current US$) in Bhutan and Value added (current US$) in Vietnam?
Offer a terse response. -4.38e+09. In the year 1994, what is the difference between the Value added (current US$) in Mauritania and Value added (current US$) in Vietnam?
Offer a terse response. -4.02e+09. In the year 1995, what is the difference between the Value added (current US$) of Other small states and Value added (current US$) of Bhutan?
Your answer should be very brief. 2.64e+09. In the year 1995, what is the difference between the Value added (current US$) of Other small states and Value added (current US$) of Mauritania?
Give a very brief answer. 2.25e+09. In the year 1995, what is the difference between the Value added (current US$) in Other small states and Value added (current US$) in Vietnam?
Your answer should be compact. -2.91e+09. In the year 1995, what is the difference between the Value added (current US$) in Bhutan and Value added (current US$) in Mauritania?
Offer a very short reply. -3.90e+08. In the year 1995, what is the difference between the Value added (current US$) of Bhutan and Value added (current US$) of Vietnam?
Your response must be concise. -5.54e+09. In the year 1995, what is the difference between the Value added (current US$) of Mauritania and Value added (current US$) of Vietnam?
Your response must be concise. -5.15e+09. In the year 1996, what is the difference between the Value added (current US$) in Other small states and Value added (current US$) in Bhutan?
Keep it short and to the point. 2.65e+09. In the year 1996, what is the difference between the Value added (current US$) in Other small states and Value added (current US$) in Mauritania?
Your answer should be compact. 2.27e+09. In the year 1996, what is the difference between the Value added (current US$) in Other small states and Value added (current US$) in Vietnam?
Make the answer very short. -4.10e+09. In the year 1996, what is the difference between the Value added (current US$) in Bhutan and Value added (current US$) in Mauritania?
Make the answer very short. -3.81e+08. In the year 1996, what is the difference between the Value added (current US$) in Bhutan and Value added (current US$) in Vietnam?
Make the answer very short. -6.75e+09. In the year 1996, what is the difference between the Value added (current US$) in Mauritania and Value added (current US$) in Vietnam?
Your response must be concise. -6.37e+09. In the year 1997, what is the difference between the Value added (current US$) in Other small states and Value added (current US$) in Bhutan?
Offer a terse response. 2.53e+09. In the year 1997, what is the difference between the Value added (current US$) of Other small states and Value added (current US$) of Mauritania?
Your answer should be compact. 2.21e+09. In the year 1997, what is the difference between the Value added (current US$) in Other small states and Value added (current US$) in Vietnam?
Provide a succinct answer. -4.28e+09. In the year 1997, what is the difference between the Value added (current US$) in Bhutan and Value added (current US$) in Mauritania?
Offer a very short reply. -3.16e+08. In the year 1997, what is the difference between the Value added (current US$) in Bhutan and Value added (current US$) in Vietnam?
Provide a succinct answer. -6.81e+09. In the year 1997, what is the difference between the Value added (current US$) in Mauritania and Value added (current US$) in Vietnam?
Give a very brief answer. -6.49e+09. In the year 1998, what is the difference between the Value added (current US$) of Other small states and Value added (current US$) of Bhutan?
Keep it short and to the point. 2.33e+09. In the year 1998, what is the difference between the Value added (current US$) in Other small states and Value added (current US$) in Mauritania?
Offer a terse response. 2.01e+09. In the year 1998, what is the difference between the Value added (current US$) of Other small states and Value added (current US$) of Vietnam?
Offer a terse response. -4.57e+09. In the year 1998, what is the difference between the Value added (current US$) in Bhutan and Value added (current US$) in Mauritania?
Make the answer very short. -3.25e+08. In the year 1998, what is the difference between the Value added (current US$) in Bhutan and Value added (current US$) in Vietnam?
Keep it short and to the point. -6.91e+09. In the year 1998, what is the difference between the Value added (current US$) of Mauritania and Value added (current US$) of Vietnam?
Offer a terse response. -6.58e+09. In the year 1999, what is the difference between the Value added (current US$) in Other small states and Value added (current US$) in Bhutan?
Provide a short and direct response. 2.33e+09. In the year 1999, what is the difference between the Value added (current US$) in Other small states and Value added (current US$) in Mauritania?
Your answer should be compact. 1.97e+09. In the year 1999, what is the difference between the Value added (current US$) of Other small states and Value added (current US$) of Vietnam?
Offer a terse response. -4.85e+09. In the year 1999, what is the difference between the Value added (current US$) of Bhutan and Value added (current US$) of Mauritania?
Offer a very short reply. -3.65e+08. In the year 1999, what is the difference between the Value added (current US$) of Bhutan and Value added (current US$) of Vietnam?
Your response must be concise. -7.19e+09. In the year 1999, what is the difference between the Value added (current US$) of Mauritania and Value added (current US$) of Vietnam?
Provide a short and direct response. -6.82e+09. In the year 2000, what is the difference between the Value added (current US$) in Other small states and Value added (current US$) in Bhutan?
Provide a short and direct response. 2.38e+09. In the year 2000, what is the difference between the Value added (current US$) in Other small states and Value added (current US$) in Mauritania?
Offer a very short reply. 2.05e+09. In the year 2000, what is the difference between the Value added (current US$) of Other small states and Value added (current US$) of Vietnam?
Give a very brief answer. -5.15e+09. In the year 2000, what is the difference between the Value added (current US$) in Bhutan and Value added (current US$) in Mauritania?
Offer a terse response. -3.27e+08. In the year 2000, what is the difference between the Value added (current US$) in Bhutan and Value added (current US$) in Vietnam?
Your answer should be compact. -7.53e+09. In the year 2000, what is the difference between the Value added (current US$) of Mauritania and Value added (current US$) of Vietnam?
Offer a terse response. -7.20e+09. In the year 2001, what is the difference between the Value added (current US$) in Other small states and Value added (current US$) in Bhutan?
Give a very brief answer. 2.24e+09. In the year 2001, what is the difference between the Value added (current US$) in Other small states and Value added (current US$) in Mauritania?
Your response must be concise. 1.93e+09. In the year 2001, what is the difference between the Value added (current US$) in Other small states and Value added (current US$) in Vietnam?
Give a very brief answer. -5.23e+09. In the year 2001, what is the difference between the Value added (current US$) in Bhutan and Value added (current US$) in Mauritania?
Keep it short and to the point. -3.13e+08. In the year 2001, what is the difference between the Value added (current US$) in Bhutan and Value added (current US$) in Vietnam?
Your answer should be very brief. -7.47e+09. In the year 2001, what is the difference between the Value added (current US$) in Mauritania and Value added (current US$) in Vietnam?
Make the answer very short. -7.16e+09. What is the ratio of the Value added (current US$) in Other small states in 1994 to that in 1995?
Your answer should be very brief. 0.89. What is the ratio of the Value added (current US$) of Bhutan in 1994 to that in 1995?
Give a very brief answer. 0.97. What is the ratio of the Value added (current US$) in Mauritania in 1994 to that in 1995?
Your response must be concise. 0.92. What is the ratio of the Value added (current US$) in Vietnam in 1994 to that in 1995?
Your answer should be very brief. 0.79. What is the ratio of the Value added (current US$) of Other small states in 1994 to that in 1996?
Offer a very short reply. 0.89. What is the ratio of the Value added (current US$) of Bhutan in 1994 to that in 1996?
Ensure brevity in your answer.  0.95. What is the ratio of the Value added (current US$) in Mauritania in 1994 to that in 1996?
Offer a terse response. 0.94. What is the ratio of the Value added (current US$) of Vietnam in 1994 to that in 1996?
Ensure brevity in your answer.  0.65. What is the ratio of the Value added (current US$) in Other small states in 1994 to that in 1997?
Your answer should be very brief. 0.92. What is the ratio of the Value added (current US$) in Bhutan in 1994 to that in 1997?
Provide a succinct answer. 0.82. What is the ratio of the Value added (current US$) in Mauritania in 1994 to that in 1997?
Your response must be concise. 1.05. What is the ratio of the Value added (current US$) of Vietnam in 1994 to that in 1997?
Keep it short and to the point. 0.65. What is the ratio of the Value added (current US$) in Bhutan in 1994 to that in 1998?
Your response must be concise. 0.84. What is the ratio of the Value added (current US$) of Mauritania in 1994 to that in 1998?
Offer a very short reply. 1.03. What is the ratio of the Value added (current US$) of Vietnam in 1994 to that in 1998?
Provide a succinct answer. 0.64. What is the ratio of the Value added (current US$) of Bhutan in 1994 to that in 1999?
Keep it short and to the point. 0.82. What is the ratio of the Value added (current US$) in Mauritania in 1994 to that in 1999?
Provide a succinct answer. 0.94. What is the ratio of the Value added (current US$) of Vietnam in 1994 to that in 1999?
Make the answer very short. 0.61. What is the ratio of the Value added (current US$) in Other small states in 1994 to that in 2000?
Ensure brevity in your answer.  0.98. What is the ratio of the Value added (current US$) of Bhutan in 1994 to that in 2000?
Provide a short and direct response. 0.77. What is the ratio of the Value added (current US$) in Vietnam in 1994 to that in 2000?
Provide a short and direct response. 0.58. What is the ratio of the Value added (current US$) in Other small states in 1994 to that in 2001?
Make the answer very short. 1.03. What is the ratio of the Value added (current US$) of Bhutan in 1994 to that in 2001?
Your answer should be compact. 0.74. What is the ratio of the Value added (current US$) in Vietnam in 1994 to that in 2001?
Give a very brief answer. 0.59. What is the ratio of the Value added (current US$) of Bhutan in 1995 to that in 1996?
Offer a very short reply. 0.98. What is the ratio of the Value added (current US$) of Mauritania in 1995 to that in 1996?
Ensure brevity in your answer.  1.01. What is the ratio of the Value added (current US$) of Vietnam in 1995 to that in 1996?
Your answer should be very brief. 0.82. What is the ratio of the Value added (current US$) in Other small states in 1995 to that in 1997?
Your response must be concise. 1.03. What is the ratio of the Value added (current US$) of Bhutan in 1995 to that in 1997?
Give a very brief answer. 0.85. What is the ratio of the Value added (current US$) of Mauritania in 1995 to that in 1997?
Your response must be concise. 1.13. What is the ratio of the Value added (current US$) of Vietnam in 1995 to that in 1997?
Offer a terse response. 0.81. What is the ratio of the Value added (current US$) in Other small states in 1995 to that in 1998?
Ensure brevity in your answer.  1.12. What is the ratio of the Value added (current US$) in Bhutan in 1995 to that in 1998?
Your answer should be very brief. 0.87. What is the ratio of the Value added (current US$) in Mauritania in 1995 to that in 1998?
Provide a short and direct response. 1.12. What is the ratio of the Value added (current US$) of Vietnam in 1995 to that in 1998?
Offer a terse response. 0.8. What is the ratio of the Value added (current US$) of Other small states in 1995 to that in 1999?
Provide a short and direct response. 1.12. What is the ratio of the Value added (current US$) of Bhutan in 1995 to that in 1999?
Provide a succinct answer. 0.85. What is the ratio of the Value added (current US$) in Mauritania in 1995 to that in 1999?
Provide a short and direct response. 1.02. What is the ratio of the Value added (current US$) in Vietnam in 1995 to that in 1999?
Give a very brief answer. 0.77. What is the ratio of the Value added (current US$) of Other small states in 1995 to that in 2000?
Keep it short and to the point. 1.09. What is the ratio of the Value added (current US$) in Bhutan in 1995 to that in 2000?
Your answer should be very brief. 0.79. What is the ratio of the Value added (current US$) in Mauritania in 1995 to that in 2000?
Offer a very short reply. 1.09. What is the ratio of the Value added (current US$) in Vietnam in 1995 to that in 2000?
Offer a terse response. 0.74. What is the ratio of the Value added (current US$) of Other small states in 1995 to that in 2001?
Offer a very short reply. 1.15. What is the ratio of the Value added (current US$) in Bhutan in 1995 to that in 2001?
Provide a short and direct response. 0.77. What is the ratio of the Value added (current US$) in Mauritania in 1995 to that in 2001?
Provide a short and direct response. 1.11. What is the ratio of the Value added (current US$) of Vietnam in 1995 to that in 2001?
Offer a very short reply. 0.74. What is the ratio of the Value added (current US$) in Other small states in 1996 to that in 1997?
Offer a terse response. 1.04. What is the ratio of the Value added (current US$) of Bhutan in 1996 to that in 1997?
Offer a very short reply. 0.87. What is the ratio of the Value added (current US$) of Mauritania in 1996 to that in 1997?
Offer a very short reply. 1.12. What is the ratio of the Value added (current US$) in Other small states in 1996 to that in 1998?
Ensure brevity in your answer.  1.12. What is the ratio of the Value added (current US$) in Bhutan in 1996 to that in 1998?
Give a very brief answer. 0.89. What is the ratio of the Value added (current US$) in Mauritania in 1996 to that in 1998?
Provide a succinct answer. 1.1. What is the ratio of the Value added (current US$) of Vietnam in 1996 to that in 1998?
Give a very brief answer. 0.98. What is the ratio of the Value added (current US$) in Other small states in 1996 to that in 1999?
Provide a succinct answer. 1.12. What is the ratio of the Value added (current US$) of Bhutan in 1996 to that in 1999?
Your answer should be compact. 0.86. What is the ratio of the Value added (current US$) in Vietnam in 1996 to that in 1999?
Offer a terse response. 0.94. What is the ratio of the Value added (current US$) in Other small states in 1996 to that in 2000?
Provide a succinct answer. 1.1. What is the ratio of the Value added (current US$) in Bhutan in 1996 to that in 2000?
Keep it short and to the point. 0.81. What is the ratio of the Value added (current US$) in Mauritania in 1996 to that in 2000?
Keep it short and to the point. 1.07. What is the ratio of the Value added (current US$) of Vietnam in 1996 to that in 2000?
Keep it short and to the point. 0.9. What is the ratio of the Value added (current US$) of Other small states in 1996 to that in 2001?
Provide a succinct answer. 1.16. What is the ratio of the Value added (current US$) of Bhutan in 1996 to that in 2001?
Provide a succinct answer. 0.78. What is the ratio of the Value added (current US$) of Mauritania in 1996 to that in 2001?
Provide a short and direct response. 1.09. What is the ratio of the Value added (current US$) in Vietnam in 1996 to that in 2001?
Your response must be concise. 0.9. What is the ratio of the Value added (current US$) of Other small states in 1997 to that in 1998?
Keep it short and to the point. 1.08. What is the ratio of the Value added (current US$) in Bhutan in 1997 to that in 1998?
Provide a succinct answer. 1.02. What is the ratio of the Value added (current US$) of Mauritania in 1997 to that in 1998?
Make the answer very short. 0.98. What is the ratio of the Value added (current US$) of Vietnam in 1997 to that in 1998?
Make the answer very short. 0.99. What is the ratio of the Value added (current US$) of Other small states in 1997 to that in 1999?
Give a very brief answer. 1.08. What is the ratio of the Value added (current US$) of Mauritania in 1997 to that in 1999?
Provide a succinct answer. 0.9. What is the ratio of the Value added (current US$) of Vietnam in 1997 to that in 1999?
Offer a terse response. 0.95. What is the ratio of the Value added (current US$) of Other small states in 1997 to that in 2000?
Your response must be concise. 1.06. What is the ratio of the Value added (current US$) of Bhutan in 1997 to that in 2000?
Your response must be concise. 0.93. What is the ratio of the Value added (current US$) of Vietnam in 1997 to that in 2000?
Offer a terse response. 0.9. What is the ratio of the Value added (current US$) in Other small states in 1997 to that in 2001?
Provide a short and direct response. 1.12. What is the ratio of the Value added (current US$) of Bhutan in 1997 to that in 2001?
Offer a terse response. 0.9. What is the ratio of the Value added (current US$) in Vietnam in 1997 to that in 2001?
Provide a succinct answer. 0.91. What is the ratio of the Value added (current US$) of Bhutan in 1998 to that in 1999?
Provide a short and direct response. 0.97. What is the ratio of the Value added (current US$) of Mauritania in 1998 to that in 1999?
Your answer should be compact. 0.91. What is the ratio of the Value added (current US$) in Vietnam in 1998 to that in 1999?
Give a very brief answer. 0.96. What is the ratio of the Value added (current US$) of Other small states in 1998 to that in 2000?
Give a very brief answer. 0.98. What is the ratio of the Value added (current US$) of Bhutan in 1998 to that in 2000?
Give a very brief answer. 0.91. What is the ratio of the Value added (current US$) in Mauritania in 1998 to that in 2000?
Offer a very short reply. 0.97. What is the ratio of the Value added (current US$) in Vietnam in 1998 to that in 2000?
Your response must be concise. 0.92. What is the ratio of the Value added (current US$) in Other small states in 1998 to that in 2001?
Provide a succinct answer. 1.03. What is the ratio of the Value added (current US$) of Bhutan in 1998 to that in 2001?
Your answer should be very brief. 0.88. What is the ratio of the Value added (current US$) of Mauritania in 1998 to that in 2001?
Your response must be concise. 0.99. What is the ratio of the Value added (current US$) in Vietnam in 1998 to that in 2001?
Give a very brief answer. 0.92. What is the ratio of the Value added (current US$) of Other small states in 1999 to that in 2000?
Your response must be concise. 0.98. What is the ratio of the Value added (current US$) in Bhutan in 1999 to that in 2000?
Offer a very short reply. 0.94. What is the ratio of the Value added (current US$) in Mauritania in 1999 to that in 2000?
Your answer should be compact. 1.07. What is the ratio of the Value added (current US$) in Vietnam in 1999 to that in 2000?
Give a very brief answer. 0.95. What is the ratio of the Value added (current US$) in Other small states in 1999 to that in 2001?
Your answer should be very brief. 1.03. What is the ratio of the Value added (current US$) of Bhutan in 1999 to that in 2001?
Provide a short and direct response. 0.91. What is the ratio of the Value added (current US$) in Mauritania in 1999 to that in 2001?
Your response must be concise. 1.09. What is the ratio of the Value added (current US$) in Vietnam in 1999 to that in 2001?
Make the answer very short. 0.96. What is the ratio of the Value added (current US$) in Other small states in 2000 to that in 2001?
Your response must be concise. 1.06. What is the ratio of the Value added (current US$) of Bhutan in 2000 to that in 2001?
Your answer should be compact. 0.97. What is the ratio of the Value added (current US$) of Mauritania in 2000 to that in 2001?
Offer a terse response. 1.02. What is the ratio of the Value added (current US$) of Vietnam in 2000 to that in 2001?
Ensure brevity in your answer.  1.01. What is the difference between the highest and the second highest Value added (current US$) in Other small states?
Your answer should be compact. 1.30e+07. What is the difference between the highest and the second highest Value added (current US$) in Bhutan?
Your response must be concise. 4.12e+06. What is the difference between the highest and the second highest Value added (current US$) in Mauritania?
Keep it short and to the point. 7.06e+06. What is the difference between the highest and the second highest Value added (current US$) of Vietnam?
Provide a succinct answer. 5.17e+07. What is the difference between the highest and the lowest Value added (current US$) in Other small states?
Give a very brief answer. 3.77e+08. What is the difference between the highest and the lowest Value added (current US$) in Bhutan?
Your response must be concise. 3.13e+07. What is the difference between the highest and the lowest Value added (current US$) in Mauritania?
Ensure brevity in your answer.  5.71e+07. What is the difference between the highest and the lowest Value added (current US$) in Vietnam?
Offer a terse response. 3.18e+09. 